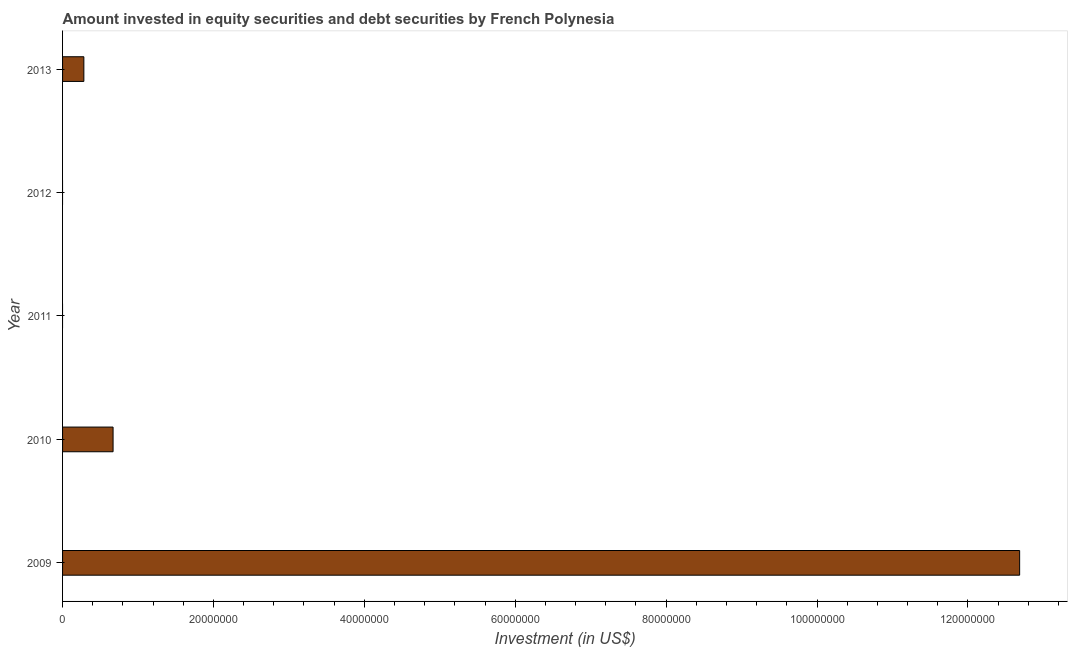Does the graph contain grids?
Offer a terse response. No. What is the title of the graph?
Provide a short and direct response. Amount invested in equity securities and debt securities by French Polynesia. What is the label or title of the X-axis?
Keep it short and to the point. Investment (in US$). What is the portfolio investment in 2010?
Give a very brief answer. 6.69e+06. Across all years, what is the maximum portfolio investment?
Your answer should be compact. 1.27e+08. Across all years, what is the minimum portfolio investment?
Give a very brief answer. 0. In which year was the portfolio investment maximum?
Give a very brief answer. 2009. What is the sum of the portfolio investment?
Provide a short and direct response. 1.36e+08. What is the difference between the portfolio investment in 2010 and 2013?
Keep it short and to the point. 3.87e+06. What is the average portfolio investment per year?
Offer a very short reply. 2.73e+07. What is the median portfolio investment?
Your answer should be very brief. 2.82e+06. What is the ratio of the portfolio investment in 2009 to that in 2013?
Your answer should be compact. 44.95. What is the difference between the highest and the second highest portfolio investment?
Provide a short and direct response. 1.20e+08. What is the difference between the highest and the lowest portfolio investment?
Provide a succinct answer. 1.27e+08. Are all the bars in the graph horizontal?
Your answer should be compact. Yes. What is the difference between two consecutive major ticks on the X-axis?
Provide a succinct answer. 2.00e+07. Are the values on the major ticks of X-axis written in scientific E-notation?
Your answer should be compact. No. What is the Investment (in US$) in 2009?
Give a very brief answer. 1.27e+08. What is the Investment (in US$) in 2010?
Your response must be concise. 6.69e+06. What is the Investment (in US$) in 2011?
Provide a succinct answer. 0. What is the Investment (in US$) of 2013?
Your answer should be compact. 2.82e+06. What is the difference between the Investment (in US$) in 2009 and 2010?
Ensure brevity in your answer.  1.20e+08. What is the difference between the Investment (in US$) in 2009 and 2013?
Make the answer very short. 1.24e+08. What is the difference between the Investment (in US$) in 2010 and 2013?
Your answer should be compact. 3.87e+06. What is the ratio of the Investment (in US$) in 2009 to that in 2010?
Provide a succinct answer. 18.95. What is the ratio of the Investment (in US$) in 2009 to that in 2013?
Provide a succinct answer. 44.95. What is the ratio of the Investment (in US$) in 2010 to that in 2013?
Your answer should be very brief. 2.37. 